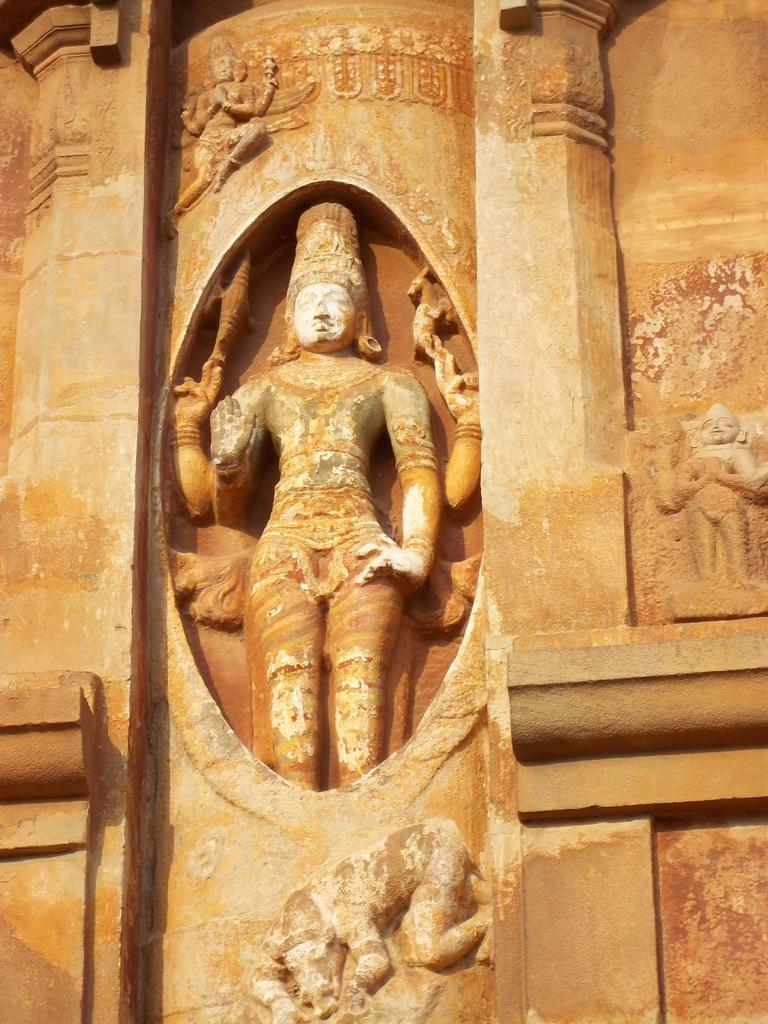What is present on the wall in the image? There are sculptures on the wall in the image. What type of ink is used to create the sculptures on the wall in the image? The fact provided does not mention any ink or materials used to create the sculptures, so we cannot determine the type of ink used. 